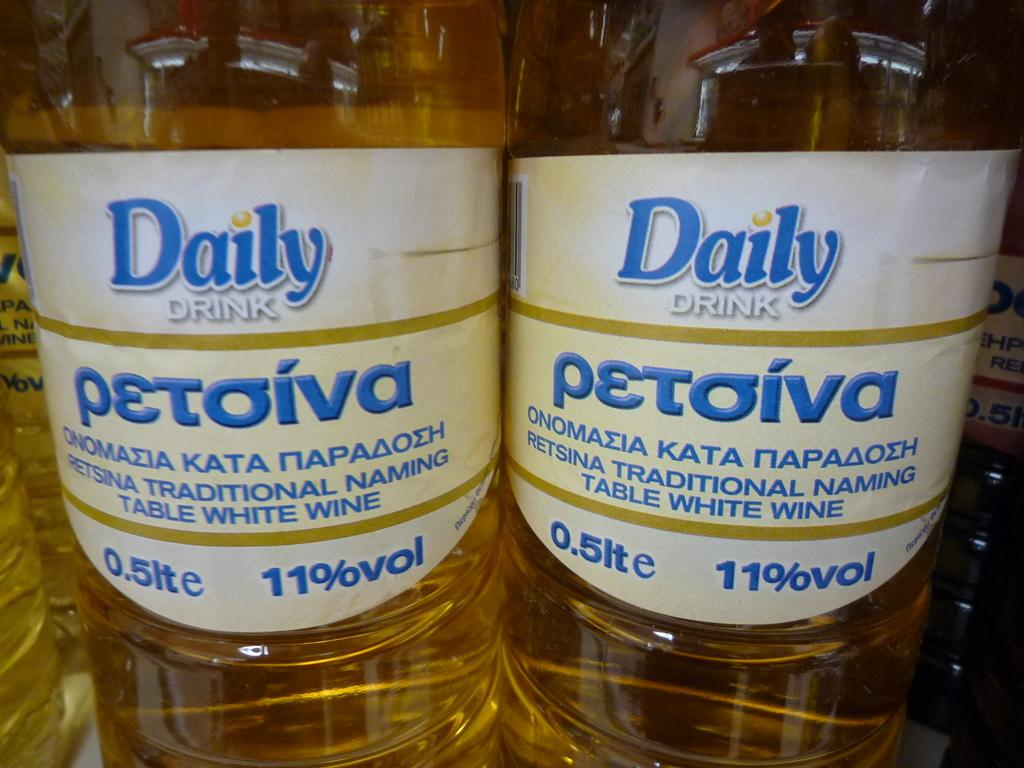How many bottles are visible in the image? There are two bottles in the image. What is inside the bottles? There is liquid in the bottles. Are there any labels or markings on the bottles? Yes, there is a sticker on each bottle. What does the sticker say? The sticker has the text "daily drink" written on it. Is there a pen visible in the image? No, there is no pen present in the image. Can you see a rat in the image? No, there is no rat present in the image. 